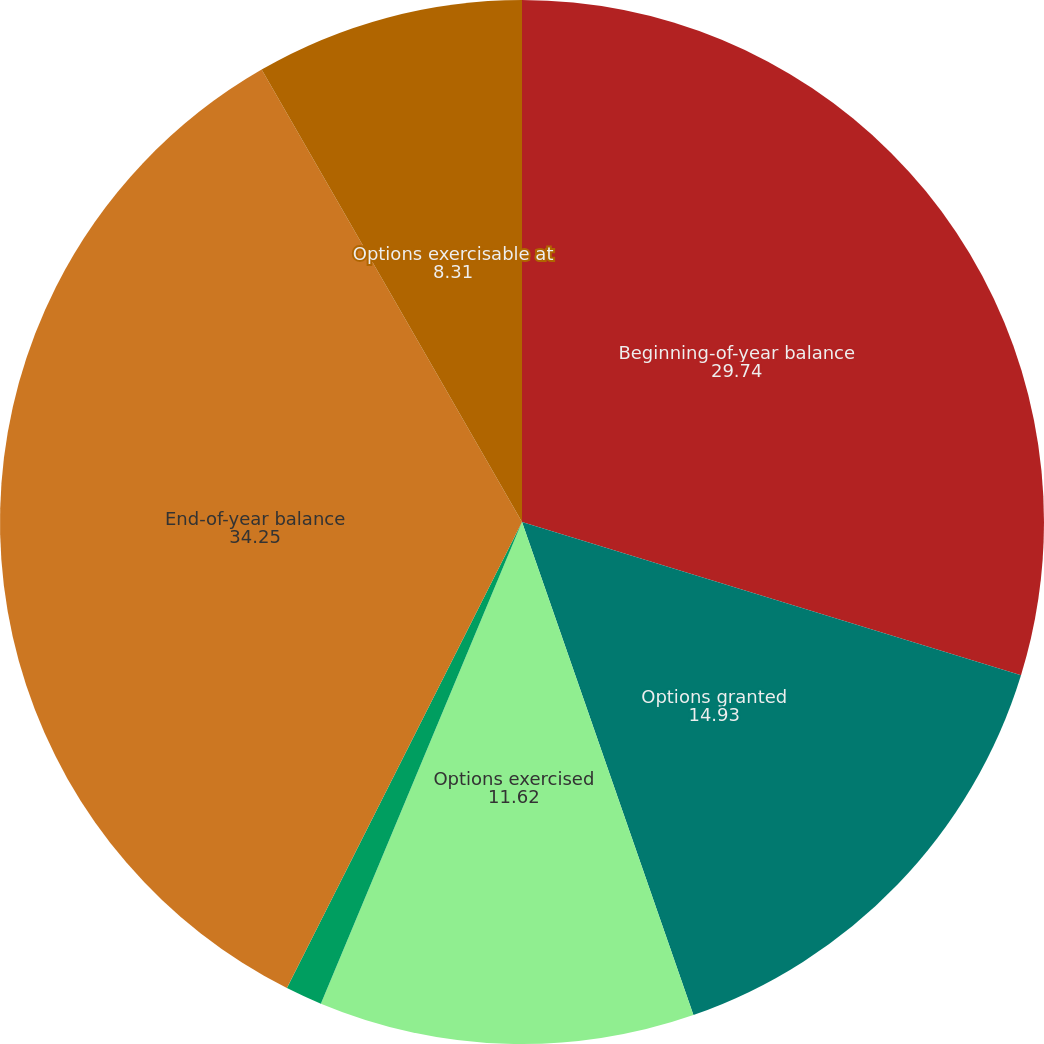<chart> <loc_0><loc_0><loc_500><loc_500><pie_chart><fcel>Beginning-of-year balance<fcel>Options granted<fcel>Options exercised<fcel>Options forfeited<fcel>End-of-year balance<fcel>Options exercisable at<nl><fcel>29.74%<fcel>14.93%<fcel>11.62%<fcel>1.14%<fcel>34.25%<fcel>8.31%<nl></chart> 